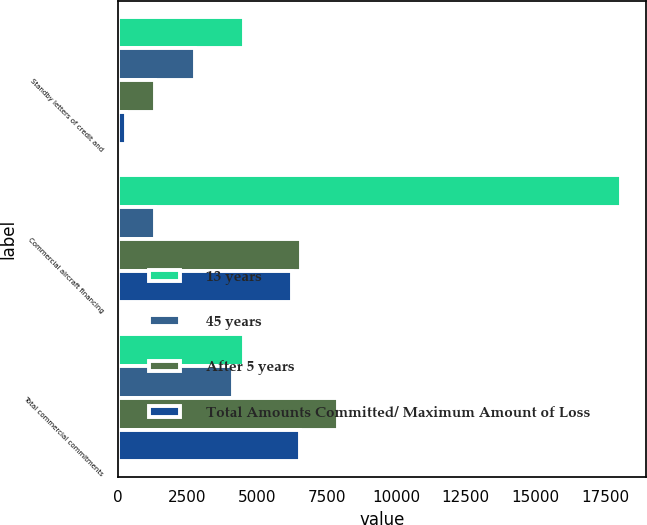Convert chart to OTSL. <chart><loc_0><loc_0><loc_500><loc_500><stacked_bar_chart><ecel><fcel>Standby letters of credit and<fcel>Commercial aircraft financing<fcel>Total commercial commitments<nl><fcel>13 years<fcel>4545<fcel>18083<fcel>4545<nl><fcel>45 years<fcel>2791<fcel>1341<fcel>4132<nl><fcel>After 5 years<fcel>1332<fcel>6588<fcel>7920<nl><fcel>Total Amounts Committed/ Maximum Amount of Loss<fcel>292<fcel>6253<fcel>6545<nl></chart> 